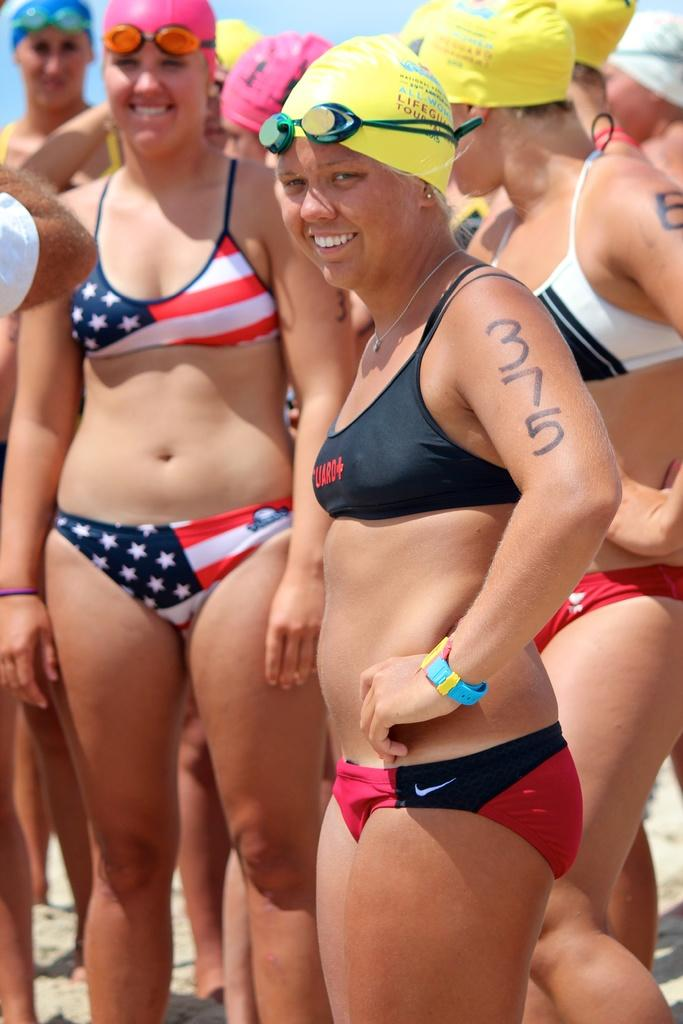What can be seen in the foreground of the image? There are women standing in the foreground of the image. What are the women wearing on their heads? The women are wearing swimming caps and glasses on their heads. What is visible in the background of the image? The sky is visible in the background of the image. Can you tell me how many frogs are sitting next to the women in the image? There are no frogs present in the image; it features women wearing swimming caps and glasses on their heads. Are the women's friends visible in the image? The provided facts do not mention any friends or other people in the image, only the women themselves. 